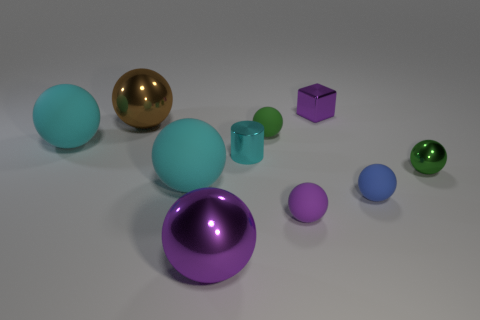There is a tiny purple rubber sphere; are there any tiny purple cubes in front of it?
Your answer should be compact. No. Is the number of small green balls that are in front of the blue rubber object the same as the number of big blue matte spheres?
Provide a short and direct response. Yes. The green rubber object that is the same size as the blue rubber sphere is what shape?
Provide a short and direct response. Sphere. What is the blue thing made of?
Your answer should be compact. Rubber. The thing that is in front of the tiny blue sphere and on the left side of the purple matte thing is what color?
Offer a terse response. Purple. Are there the same number of big purple metallic balls that are on the left side of the tiny block and blue rubber things to the left of the large purple shiny ball?
Your answer should be very brief. No. What color is the block that is made of the same material as the brown sphere?
Provide a short and direct response. Purple. There is a cylinder; is its color the same as the tiny shiny thing that is behind the green rubber object?
Your answer should be very brief. No. Are there any rubber objects that are in front of the cyan thing that is right of the metallic ball that is in front of the tiny blue object?
Your response must be concise. Yes. There is a large purple object that is made of the same material as the tiny cyan cylinder; what shape is it?
Offer a terse response. Sphere. 